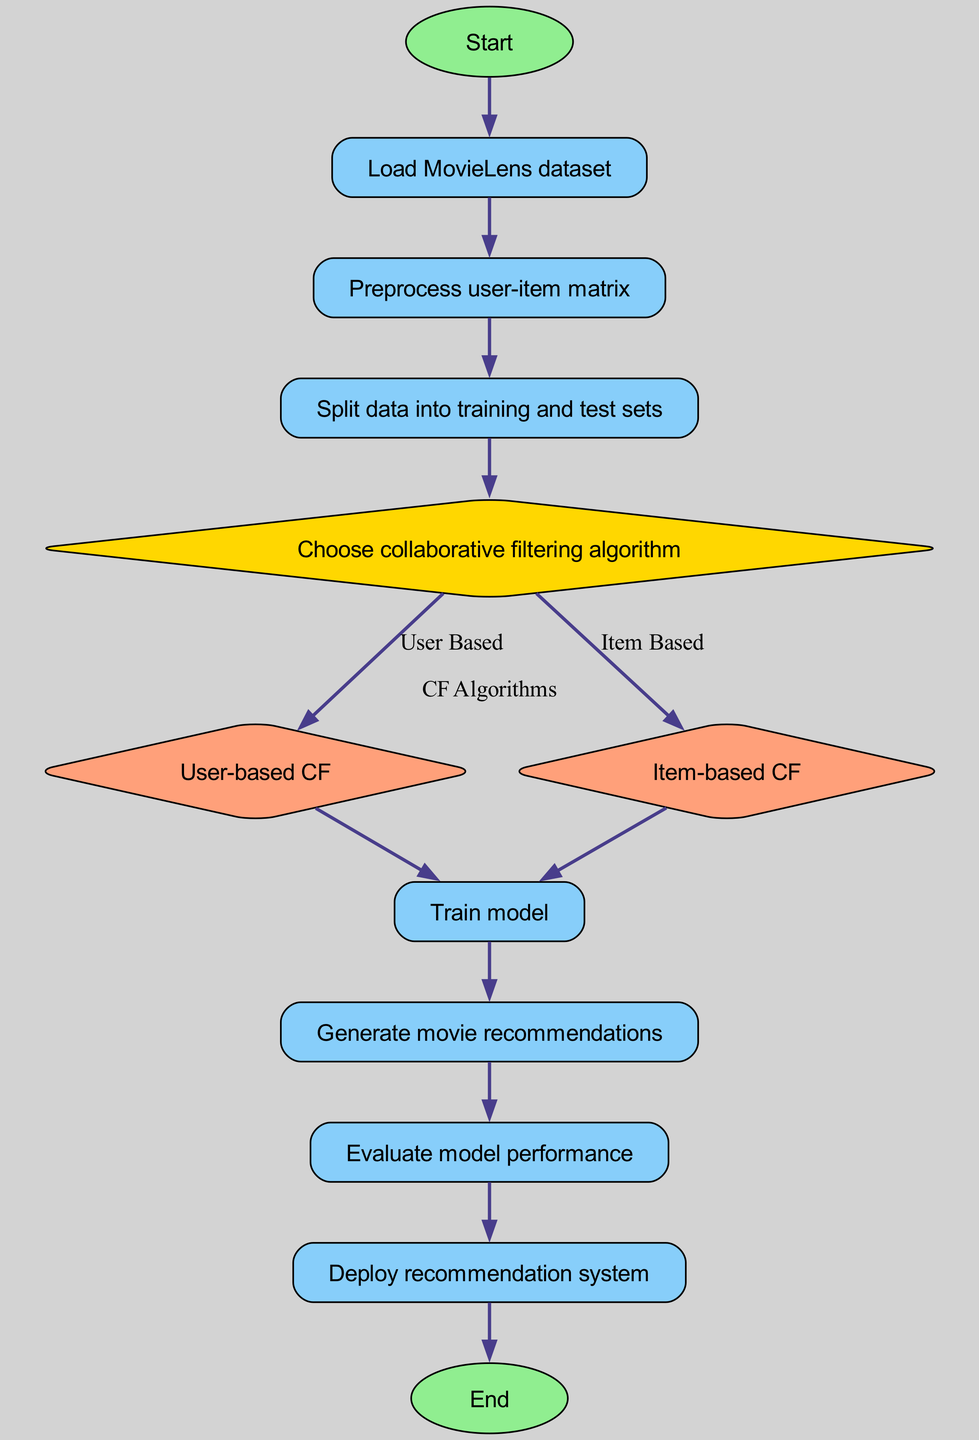What is the first step in the collaborative filtering process? The first step in the diagram is the "Start" node, which leads to the "Load MovieLens dataset." Hence, the initial step is the start itself.
Answer: Start How many collaborative filtering algorithms are chosen? In the diagram, under the "Choose collaborative filtering algorithm" node, there are two options shown, "User-based CF" and "Item-based CF." This indicates that there are two algorithms to choose from.
Answer: Two What comes after training the model? After the "Train model" step, the next node is "Generate movie recommendations." Therefore, the step that follows training the model is generating recommendations.
Answer: Generate movie recommendations What type of nodes are used for "User-based CF" and "Item-based CF"? In the diagram, both "User-based CF" and "Item-based CF" are represented as diamond-shaped nodes, indicating a decision point or selection in the process flow.
Answer: Diamond Which node follows directly after evaluating the model's performance? Directly after "Evaluate model performance," the next step is "Deploy recommendation system." This shows the progression from evaluation to deployment.
Answer: Deploy recommendation system What is indicated by the shape of the "Choose collaborative filtering algorithm" node? The shape of the "Choose collaborative filtering algorithm" node is a diamond, which signifies that it represents a choice or a decision point in the flow chart.
Answer: Decision point In the flow chart, how do you transition from data splitting to algorithm choice? The transition from "Split data into training and test sets" to "Choose collaborative filtering algorithm" is a direct flow indicated by an arrow connecting these two nodes. Therefore, it is a straightforward transition.
Answer: Direct flow What action occurs immediately after data preprocessing? Immediately after "Preprocess user-item matrix," the next action in the flow chart is "Split data into training and test sets." This indicates the sequence of steps post-preprocessing.
Answer: Split data into training and test sets What do the colored shapes signify in this flow chart? The different shapes and colors in the flow chart signify the types of actions or decisions: oval shapes for start/end, rectangles for processes, and diamonds for decision points.
Answer: Types of actions and decisions 